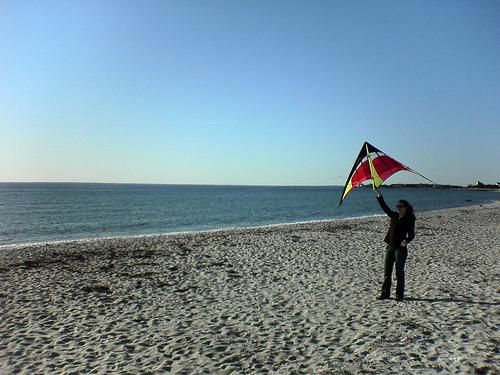Is the person in the black shirt a man or a woman?
Answer briefly. Woman. What kind of attire is she wearing?
Keep it brief. Casual. Is it hot out?
Be succinct. No. What is the woman holding in her hand?
Give a very brief answer. Kite. Is there an umbrella?
Quick response, please. No. Does it look warm enough to wear a swimming suit?
Keep it brief. No. Where is the picture taken?
Give a very brief answer. Beach. What is the woman standing on?
Short answer required. Sand. Is the sky the same color as the water?
Be succinct. Yes. How many men are in the photo?
Be succinct. 0. What is the child holding?
Answer briefly. Kite. 